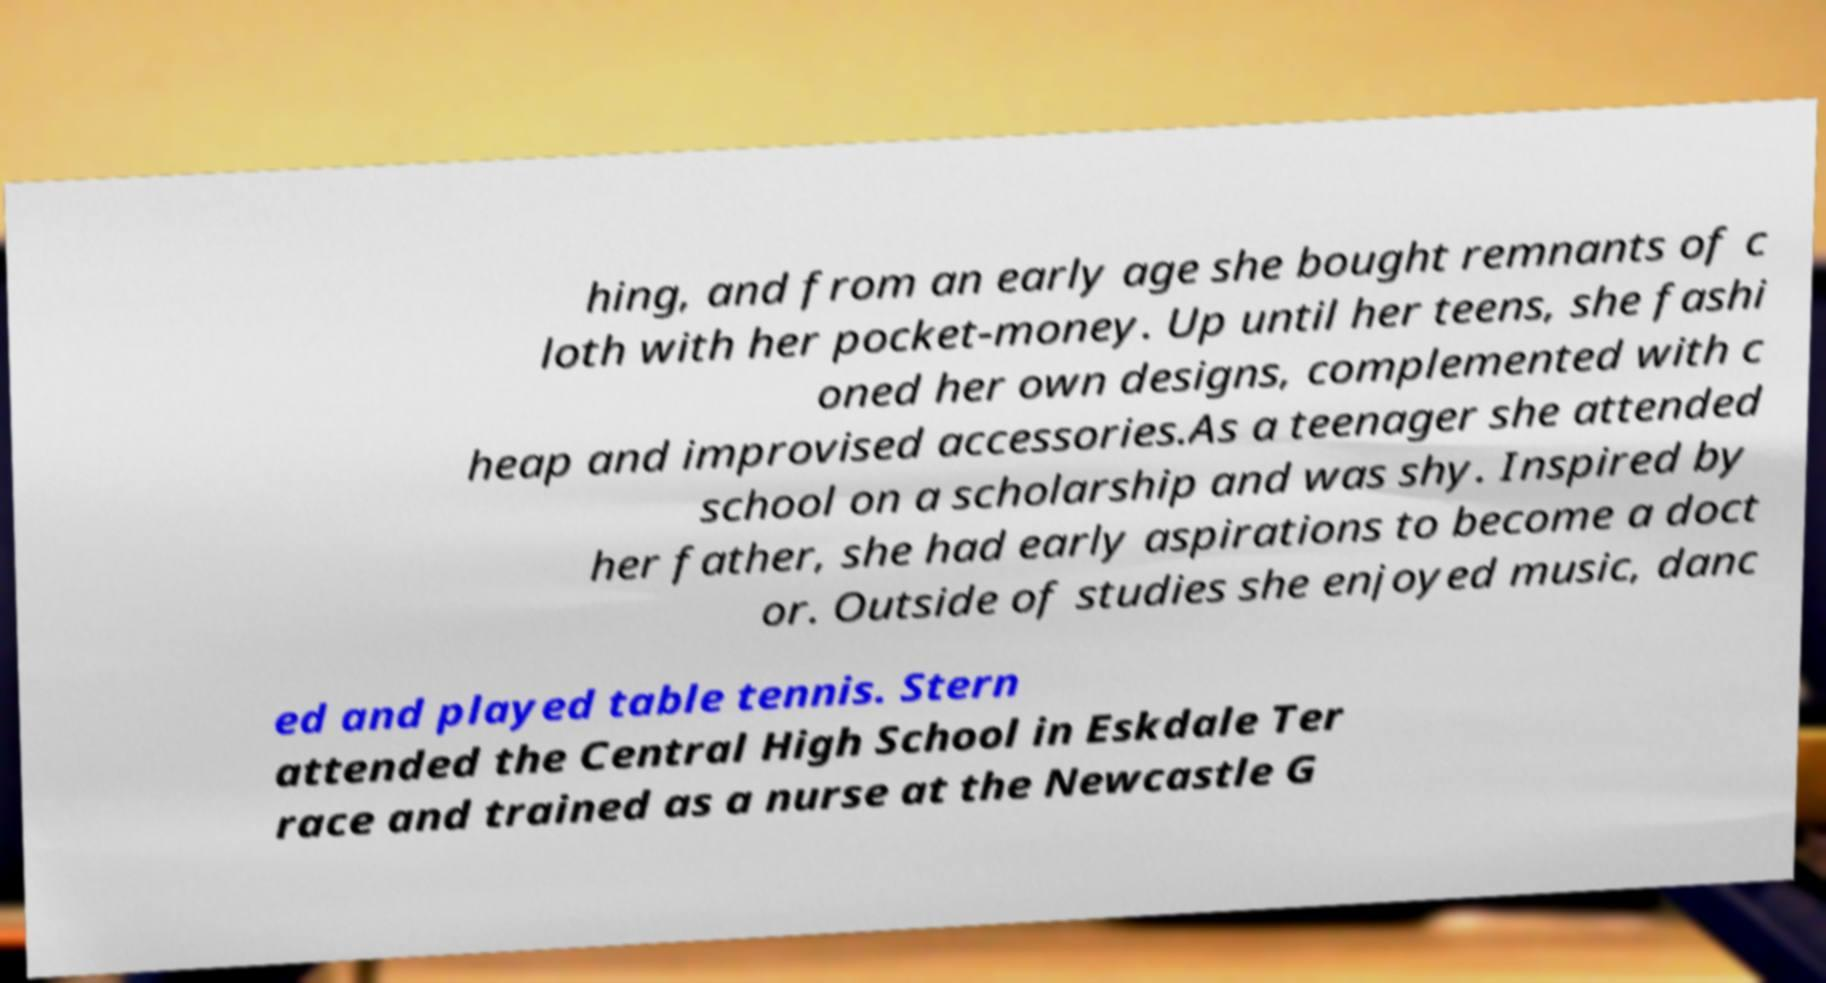There's text embedded in this image that I need extracted. Can you transcribe it verbatim? hing, and from an early age she bought remnants of c loth with her pocket-money. Up until her teens, she fashi oned her own designs, complemented with c heap and improvised accessories.As a teenager she attended school on a scholarship and was shy. Inspired by her father, she had early aspirations to become a doct or. Outside of studies she enjoyed music, danc ed and played table tennis. Stern attended the Central High School in Eskdale Ter race and trained as a nurse at the Newcastle G 